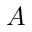Convert formula to latex. <formula><loc_0><loc_0><loc_500><loc_500>A</formula> 